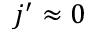<formula> <loc_0><loc_0><loc_500><loc_500>j ^ { \prime } \approx 0</formula> 